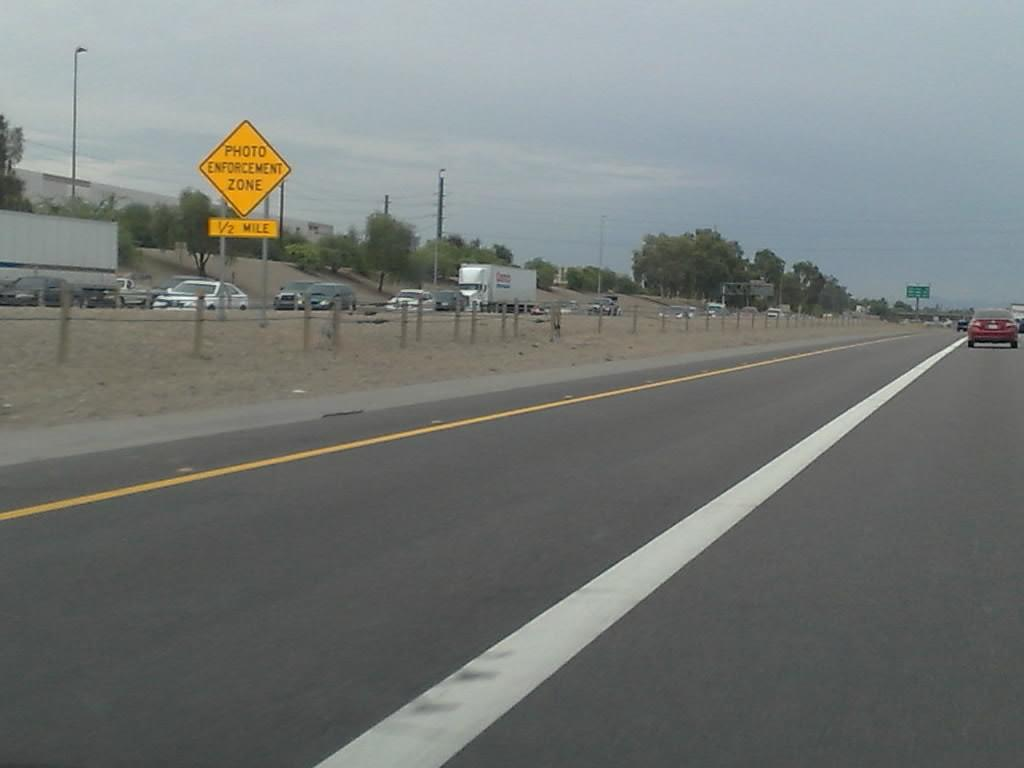<image>
Summarize the visual content of the image. A half mile up ahead is a photo enforcement zone. 